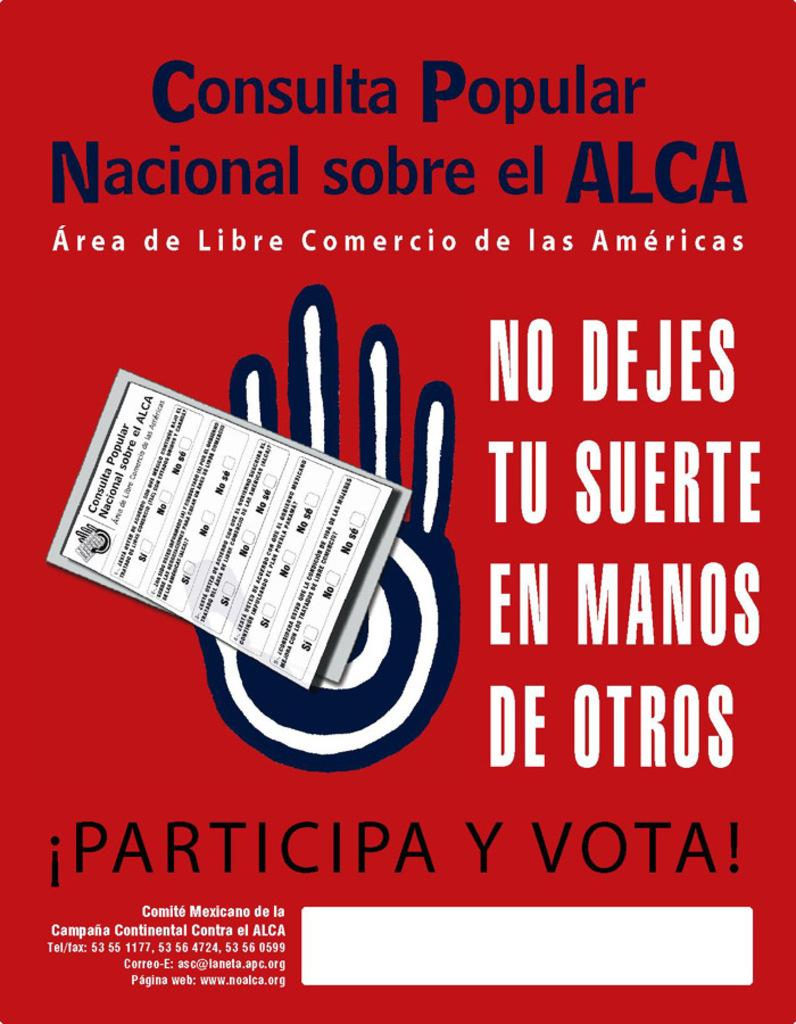<image>
Provide a brief description of the given image. A red flyer that says Consulata Popular at the top of it. 